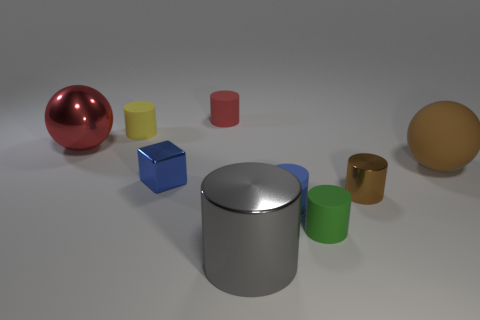Are all the objects made of the same material, or do they differ? While an image alone cannot definitively determine material composition, the objects do have different surface properties that suggest a variety of materials. Some objects have a matte finish, while others are shiny, which implies that there could be different materials like plastic, metal, or even ceramic present. 